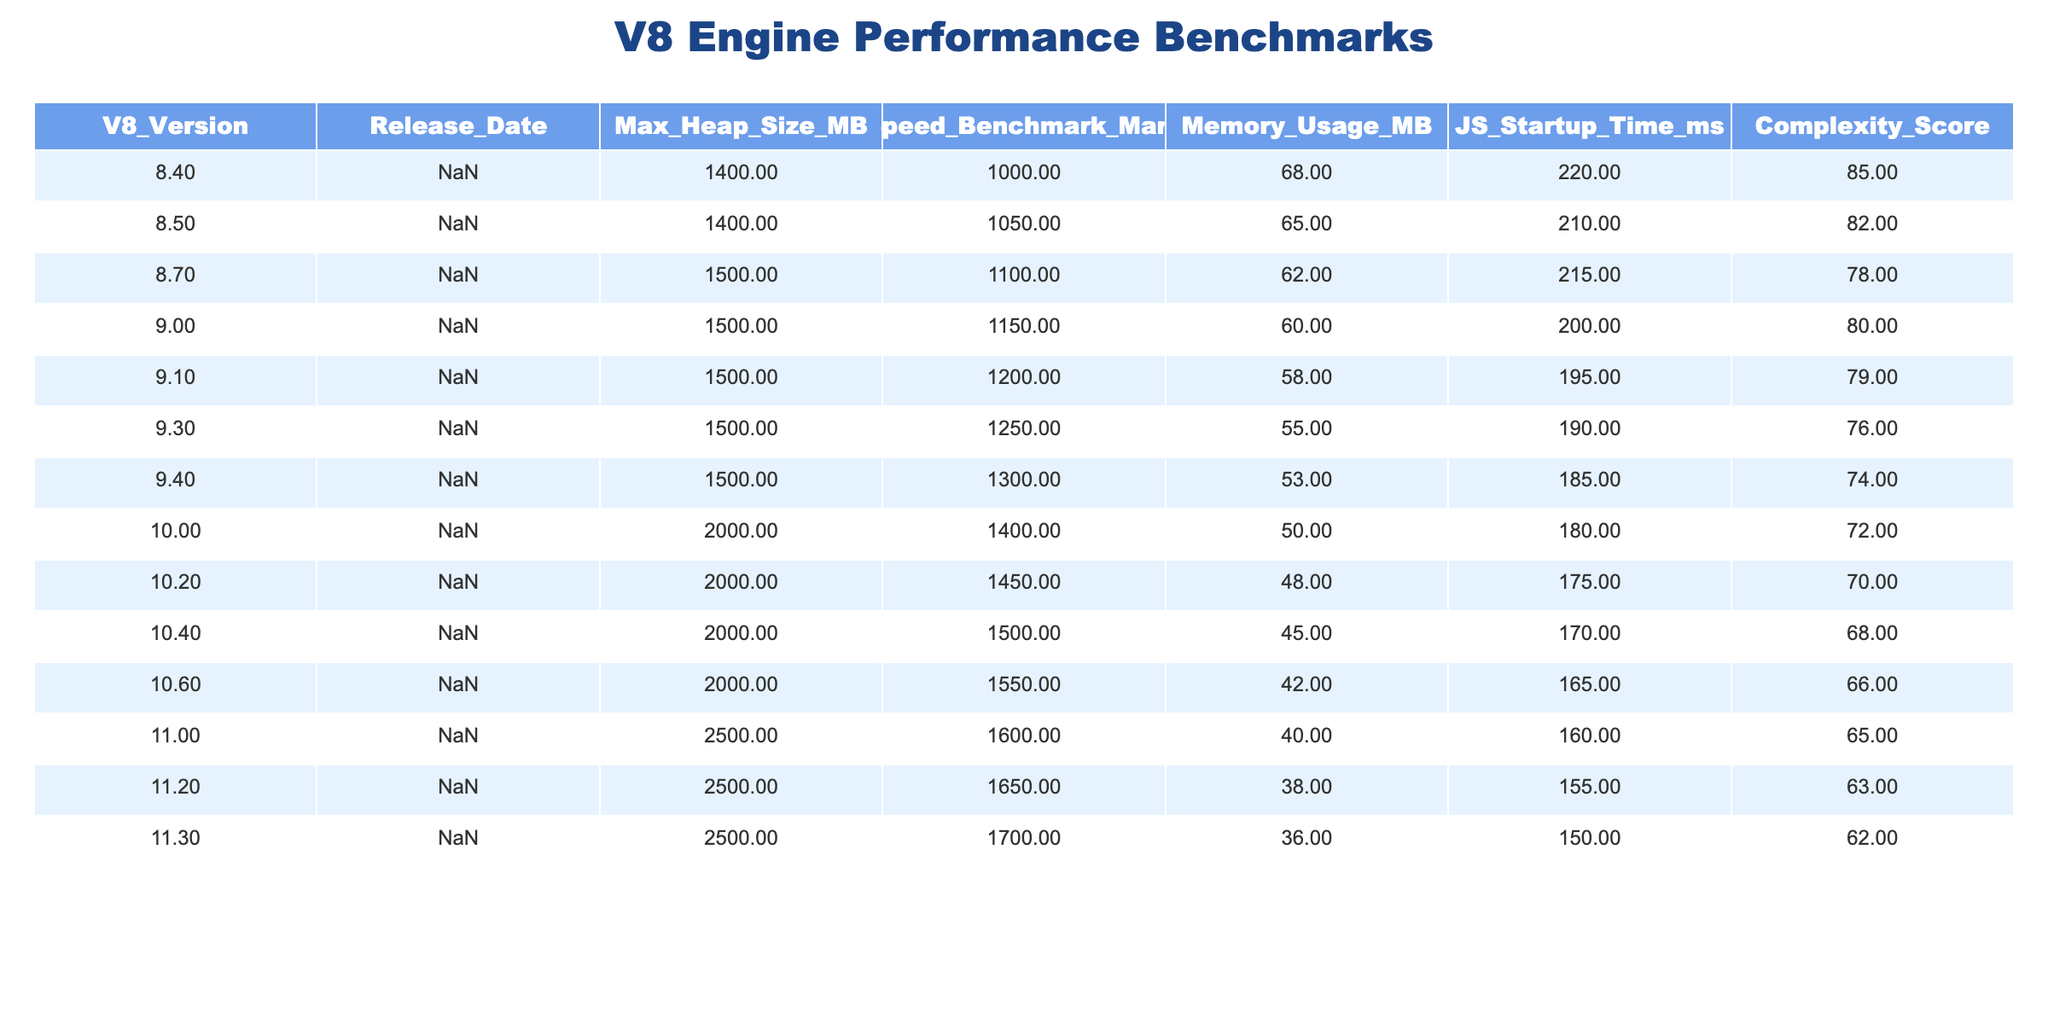What is the maximum heap size for V8 version 10.4? The table lists the maximum heap size for each version under the column "Max_Heap_Size_MB." For V8 version 10.4, the value is 2000 MB.
Answer: 2000 MB Which V8 version has the best speed benchmark mark? To determine this, I look at the "Speed_Benchmark_Mark" column and find the highest value. The highest mark is 1700 for V8 version 11.3.
Answer: 1700 What is the average memory usage for versions after 10.0? For versions after 10.0, I sum the memory usages: 40 + 38 + 36 = 114 MB. There are 3 versions, so the average is 114/3 = 38 MB.
Answer: 38 MB Is the JS startup time for version 9.1 lower than that for version 9.3? For version 9.1, the startup time is 195 ms, while for version 9.3, it is 190 ms. Since 195 is greater than 190, this statement is false.
Answer: No What is the difference in the speed benchmark marks between version 9.0 and version 10.2? Version 9.0 has a speed benchmark mark of 1150 and version 10.2 has a mark of 1450. The difference is 1450 - 1150 = 300.
Answer: 300 Which version has the lowest complexity score? I look through the "Complexity_Score" column for the lowest value and find that version 11.3 has the lowest score, which is 62.
Answer: 62 What is the maximum speed benchmark mark for versions 8.x? From the "Speed_Benchmark_Mark" column for versions 8.x, I find that version 8.7 has the highest mark of 1100.
Answer: 1100 How many versions have a maximum heap size of 1500 MB or more? Counting the versions with a maximum heap size of 1500 MB or more, I find 7 versions (8.7, 9.0, 9.1, 9.3, 9.4, 10.0, 10.2, 10.4, 10.6, 11.0, 11.2, 11.3).
Answer: 7 